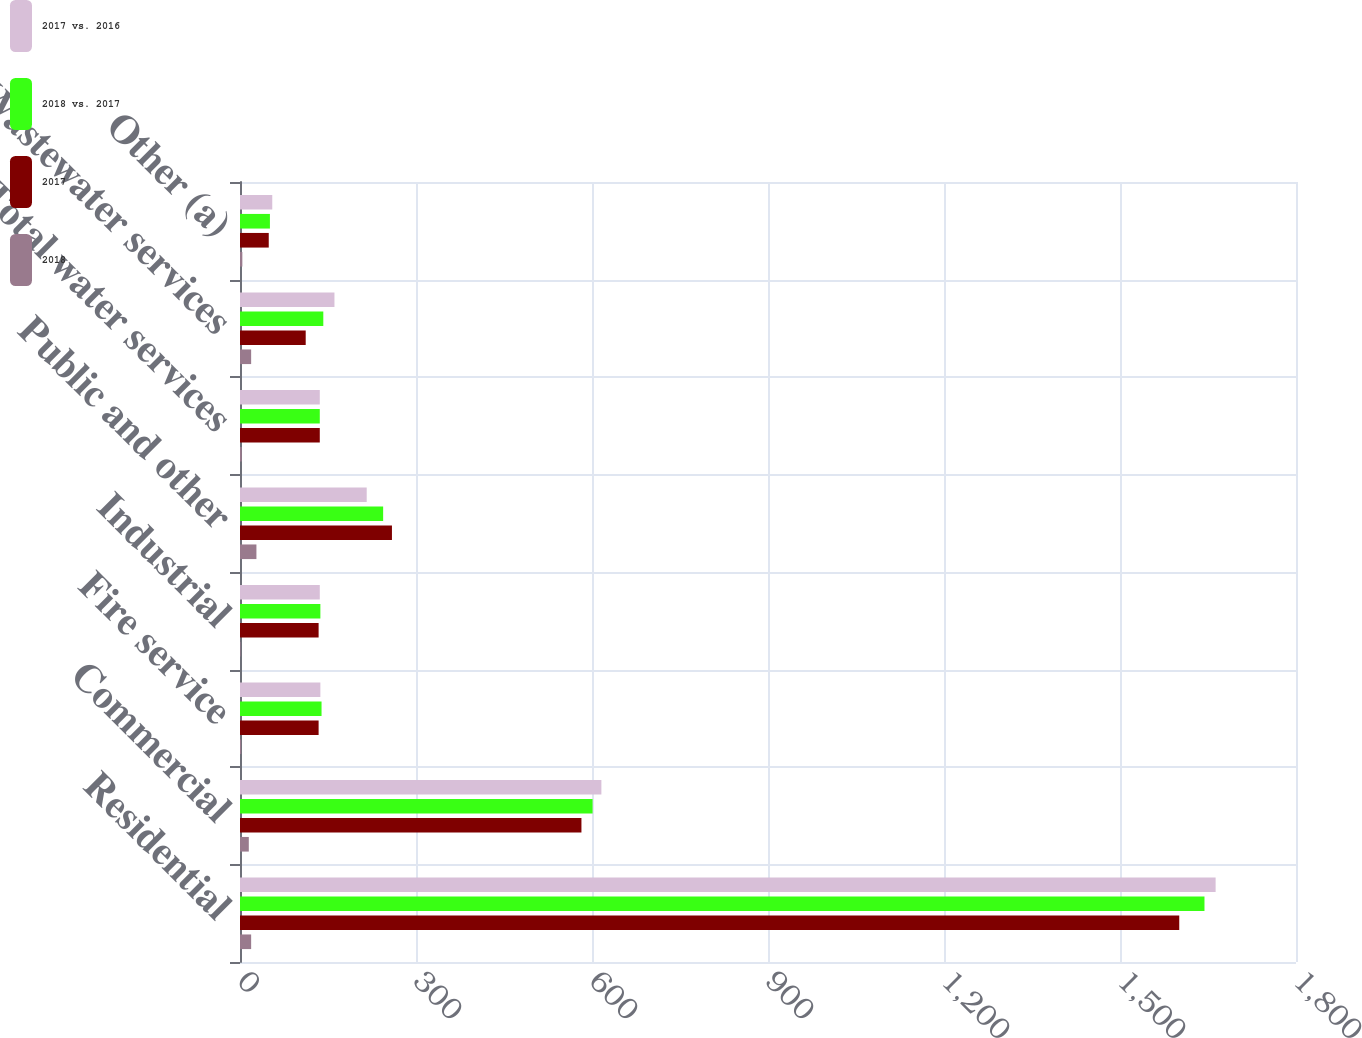<chart> <loc_0><loc_0><loc_500><loc_500><stacked_bar_chart><ecel><fcel>Residential<fcel>Commercial<fcel>Fire service<fcel>Industrial<fcel>Public and other<fcel>Total water services<fcel>Wastewater services<fcel>Other (a)<nl><fcel>2017 vs. 2016<fcel>1663<fcel>616<fcel>137<fcel>136<fcel>216<fcel>136<fcel>161<fcel>55<nl><fcel>2018 vs. 2017<fcel>1644<fcel>601<fcel>139<fcel>137<fcel>244<fcel>136<fcel>142<fcel>51<nl><fcel>2017<fcel>1601<fcel>582<fcel>134<fcel>134<fcel>259<fcel>136<fcel>112<fcel>49<nl><fcel>2018<fcel>19<fcel>15<fcel>2<fcel>1<fcel>28<fcel>3<fcel>19<fcel>4<nl></chart> 